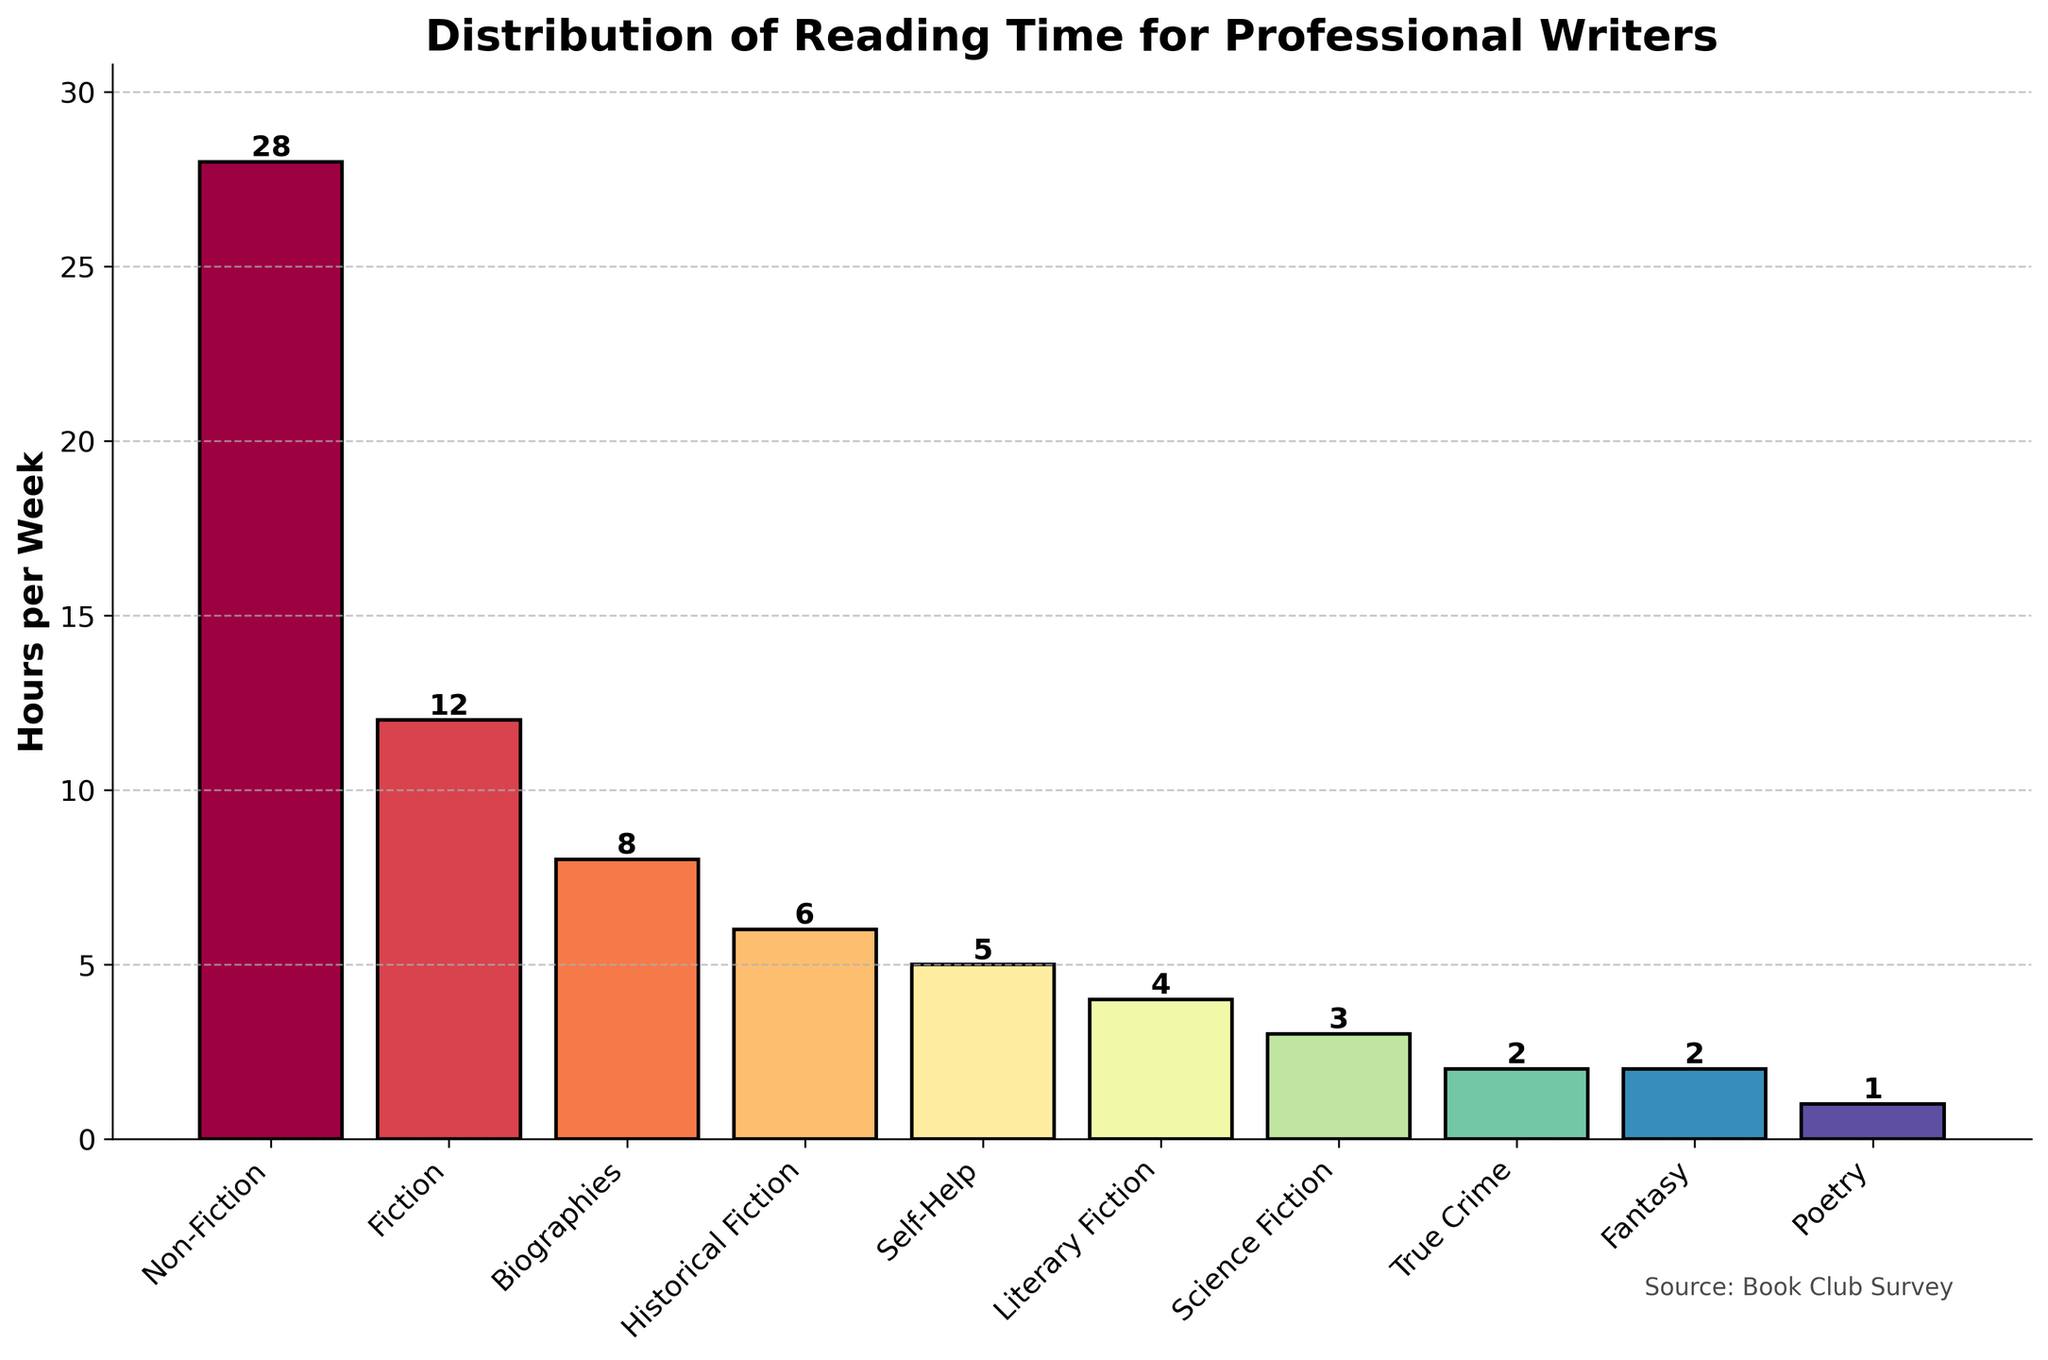What are the genres with more than 10 hours of reading per week? By observing the chart, we can identify the bars with heights greater than 10 hours. Non-Fiction has 28 hours and Fiction has 12 hours, both are greater than 10 hours.
Answer: Non-Fiction, Fiction Which genre has the least reading time per week? The shortest bar on the chart represents the genre with the least amount of reading time per week. Poetry has a reading time of 1 hour, which is the smallest.
Answer: Poetry What is the total reading time for fiction genres (including Fiction, Historical Fiction, Literary Fiction, Science Fiction, and Fantasy)? To calculate the total reading time, we sum the hours of each fiction genre: Fiction (12) + Historical Fiction (6) + Literary Fiction (4) + Science Fiction (3) + Fantasy (2) = 27 hours.
Answer: 27 hours How much more time is spent reading Non-Fiction compared to Fiction? The bar for Non-Fiction represents 28 hours and the bar for Fiction represents 12 hours. The difference is 28 - 12 = 16 hours.
Answer: 16 hours Which genres have reading times between 5 and 10 hours per week? By checking the bars that represent the hours between 5 and 10, we find Biographies with 8 hours, Historical Fiction with 6 hours, and Self-Help with 5 hours.
Answer: Biographies, Historical Fiction, Self-Help How does the combined reading time of Science Fiction and Fantasy compare to Biographies? Science Fiction has 3 hours, and Fantasy has 2 hours. Their combined time is 3 + 2 = 5 hours. Biographies have 8 hours. Thus, 8 hours (Biographies) - 5 hours (Science Fiction and Fantasy) = 3 hours more for Biographies.
Answer: 3 hours more for Biographies What is the average reading time for the genres listed in the chart? To find the average, sum all reading times and divide by the number of genres: (28 + 12 + 8 + 6 + 5 + 4 + 3 + 2 + 2 + 1) = 71 hours. There are 10 genres, so the average is 71 / 10 = 7.1 hours.
Answer: 7.1 hours Which genre is read more, Self-Help or True Crime, and by how much? The bar for Self-Help shows 5 hours, and the bar for True Crime shows 2 hours. The difference is 5 - 2 = 3 hours.
Answer: Self-Help by 3 hours What proportion of the total reading time is spent on Fiction? The sum of reading times is 71 hours. Fiction’s reading time is 12 hours. The proportion is 12 / 71 ≈ 0.169 or 16.9%.
Answer: 16.9% Which genre has a bar colored similarly to Fantasy but with a different reading time? Observing the colors, True Crime has a similar color to Fantasy (they both share a red-pinkish tone) but has a different reading time of 2 hours compared to Fantasy's 2.
Answer: True Crime 